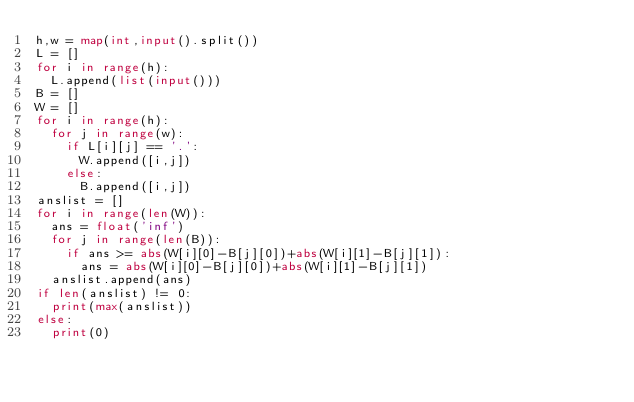Convert code to text. <code><loc_0><loc_0><loc_500><loc_500><_Python_>h,w = map(int,input().split())
L = []
for i in range(h):
  L.append(list(input()))
B = []
W = []
for i in range(h):
  for j in range(w):
    if L[i][j] == '.':
      W.append([i,j])
    else:
      B.append([i,j])
anslist = []
for i in range(len(W)):
  ans = float('inf')
  for j in range(len(B)):
    if ans >= abs(W[i][0]-B[j][0])+abs(W[i][1]-B[j][1]):
      ans = abs(W[i][0]-B[j][0])+abs(W[i][1]-B[j][1])
  anslist.append(ans)
if len(anslist) != 0:
  print(max(anslist))
else:
  print(0)</code> 